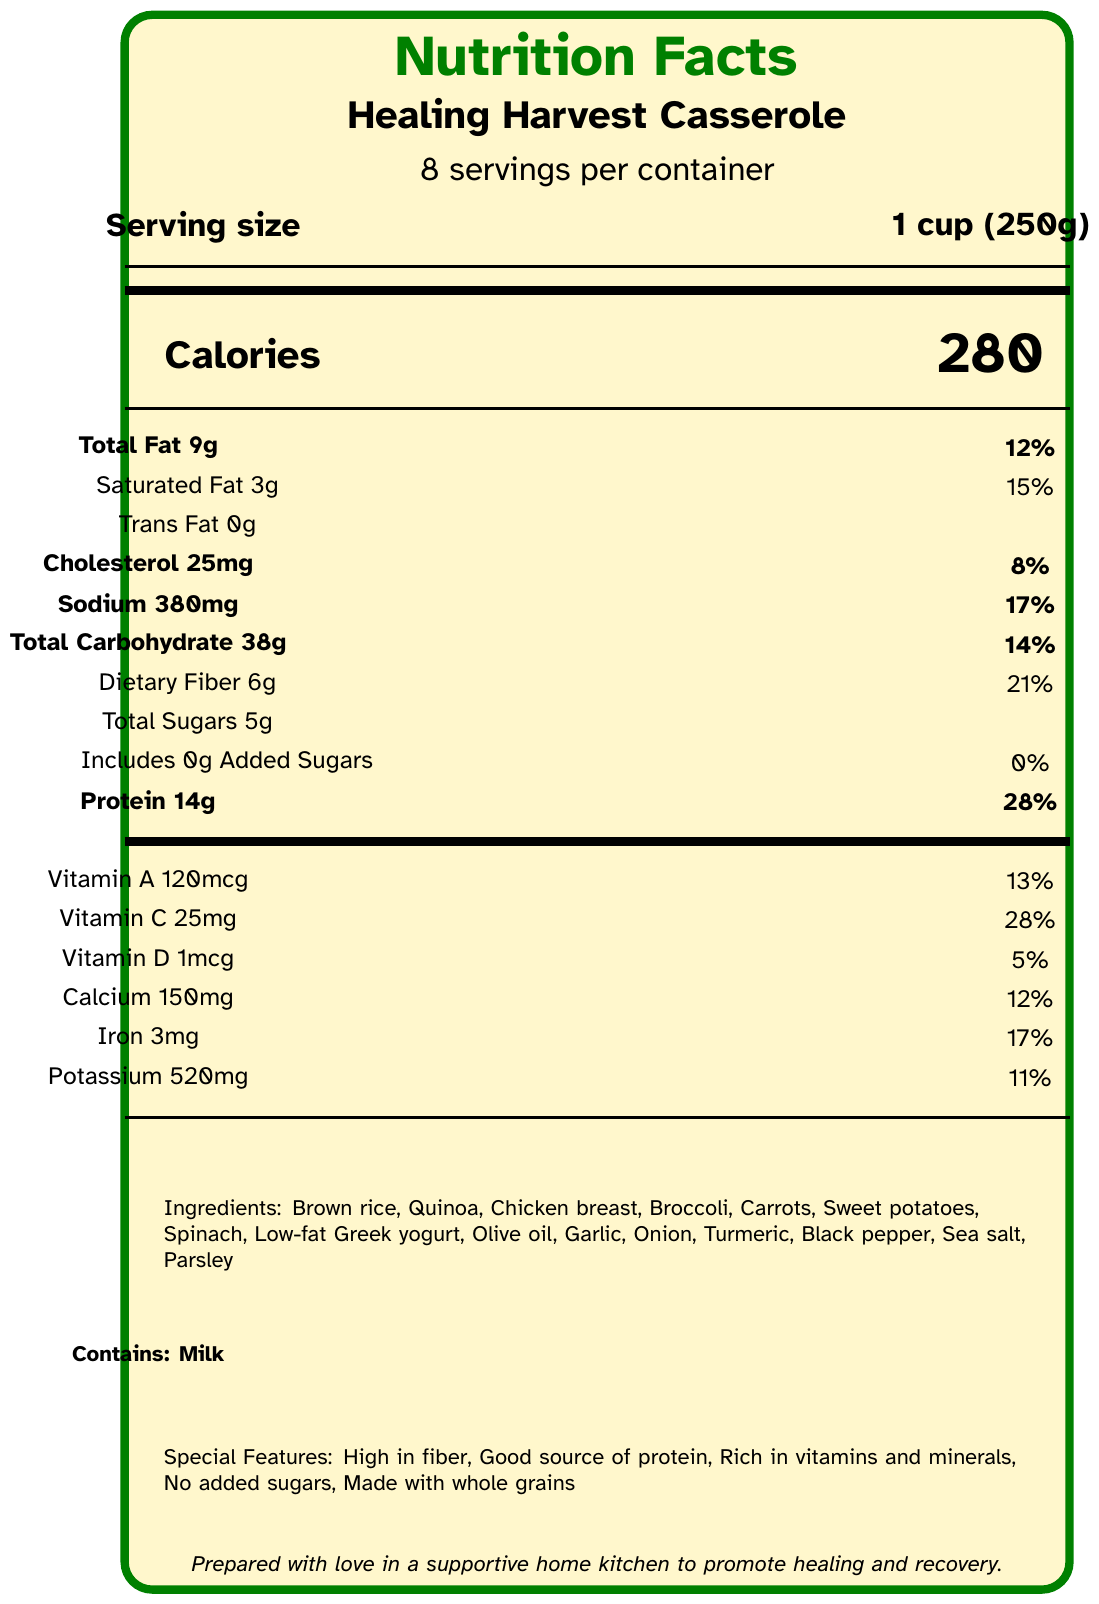what is the serving size of Healing Harvest Casserole? The serving size is explicitly stated as "1 cup (250g)" under the product name on the label.
Answer: 1 cup (250g) how many servings are there per container? The label states "8 servings per container" below the product name.
Answer: 8 servings what are the total calories per serving? The label lists "Calories" as 280 under the serving size information.
Answer: 280 calories how much total fat does one serving contain? The "Total Fat" content is listed as 9g next to the percentage daily value information.
Answer: 9g how much dietary fiber is in one serving? The dietary fiber content is stated as 6g next to the percentage daily value.
Answer: 6g does this product contain any trans fat? The "Trans Fat" content is given as 0g, indicating none is present.
Answer: No what is the main protein source in this casserole? The ingredients list includes "Chicken breast," which is a primary source of protein.
Answer: Chicken breast how many grams of added sugars are in each serving? The label specifies "Includes 0g Added Sugars," indicating there are no added sugars.
Answer: 0g which of the following vitamins has the highest percentage daily value in one serving? A. Vitamin A B. Vitamin C C. Vitamin D D. Calcium Vitamin C has the highest percentage daily value at 28%, as shown on the label.
Answer: B how much sodium is in one serving? A. 120mg B. 150mg C. 320mg D. 380mg The total sodium content is listed as 380mg per serving on the label.
Answer: D is this product high in fiber? The label clearly states "High in fiber," and the dietary fiber content of 6g per serving supports this claim.
Answer: Yes what are the storage instructions for this casserole? The bottom section of the label provides the storage instructions, stating to keep refrigerated, consume within 3-4 days, and it can be frozen for up to 1 month.
Answer: Keep refrigerated. Consume within 3-4 days. Can be frozen for up to 1 month. are there any allergens listed for this product? The label states "Contains: Milk," indicating that it contains milk.
Answer: Yes describe the main features of the Healing Harvest Casserole. The label illustrates that this casserole is designed to help with healing and recovery. It highlights various health benefits, such as being high in fiber and rich in protein, vitamins, and minerals, and it uses whole grains with no added sugars.
Answer: The Healing Harvest Casserole is a nutritious, family-style dish made with whole grains, vegetables, and chicken breast. It's high in fiber, a good source of protein, rich in vitamins and minerals, and contains no added sugars. It promotes healing and recovery. how should individual portions be reheated? The reheating instructions at the bottom of the label advise microwaving for 2-3 minutes and suggest adding a splash of water for best results.
Answer: Microwave individual portions for 2-3 minutes or until heated through. For best results, add a splash of water before reheating. can this document be found on the manufacturer's website? The document does not provide any information about the availability or location of this specific label on a website.
Answer: Cannot be determined 